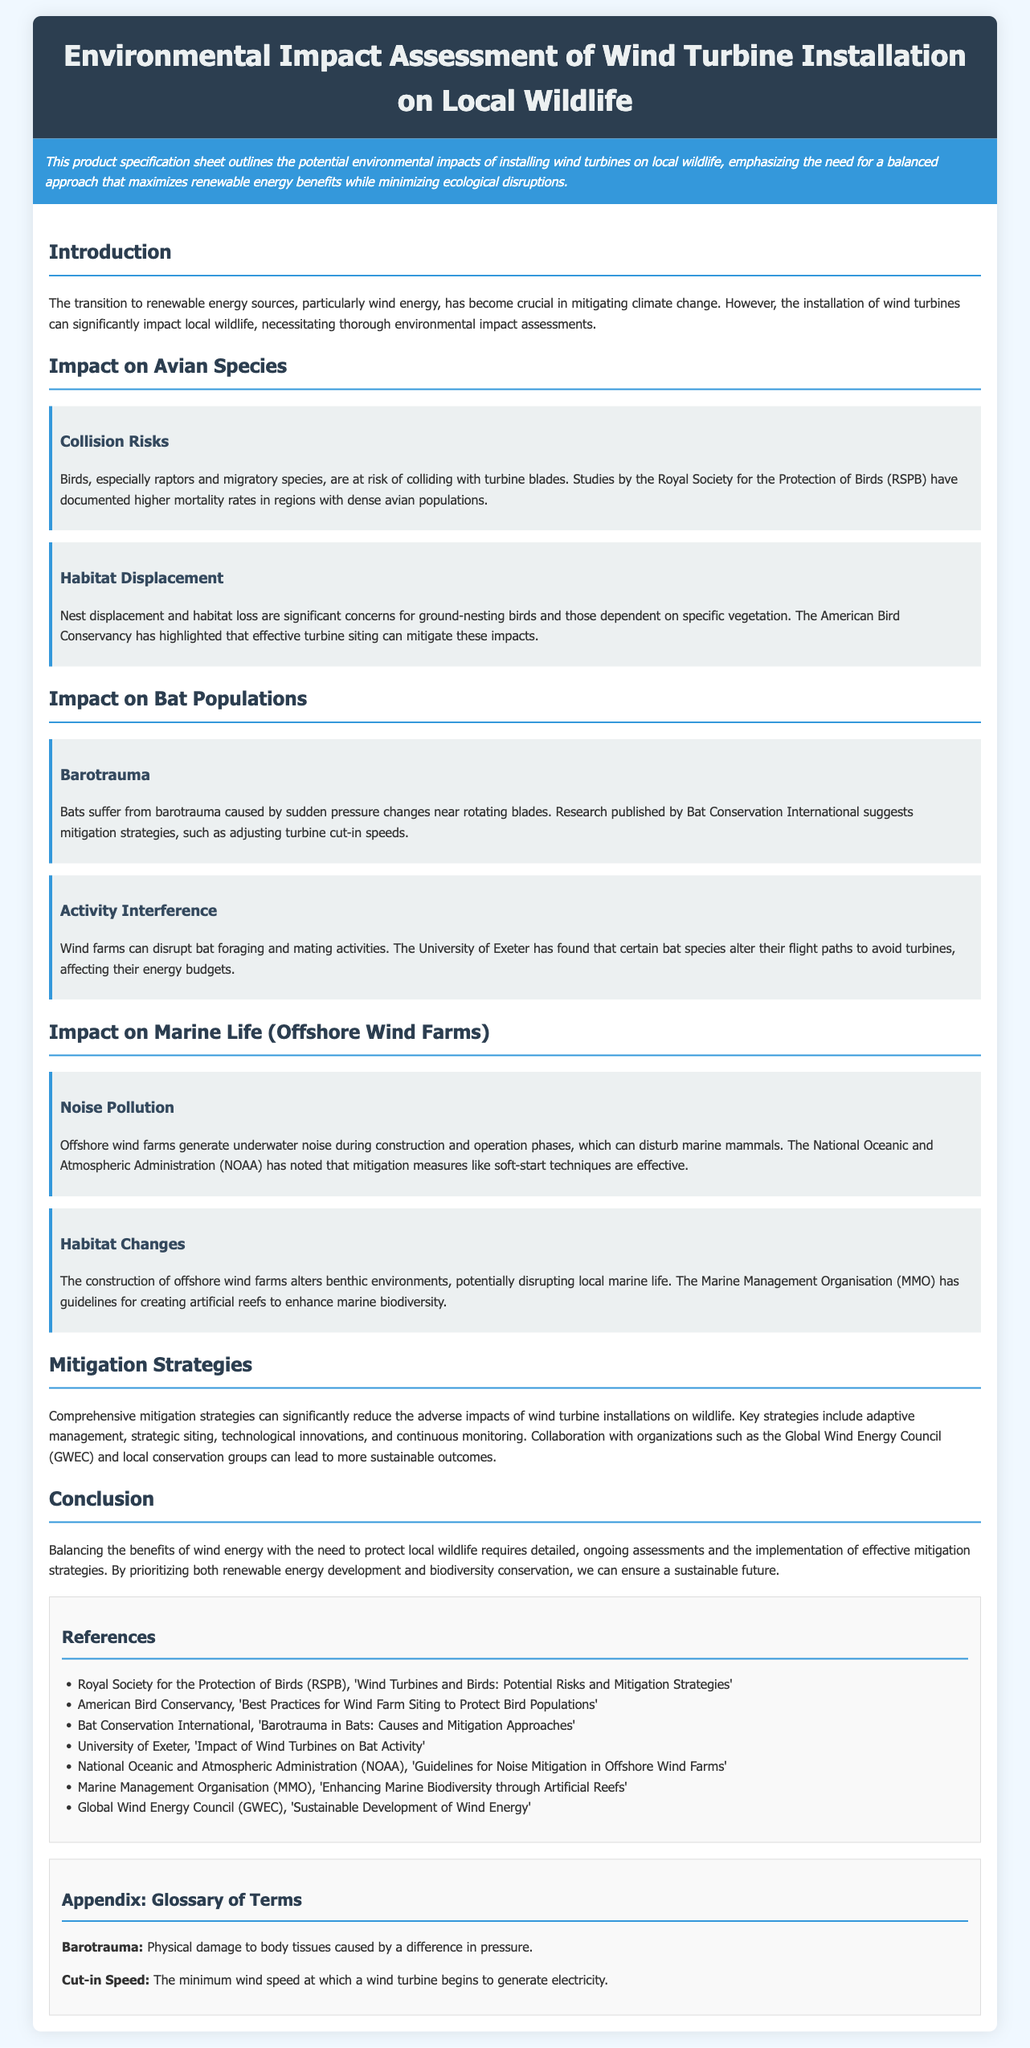What is the title of the document? The title is stated at the top of the document, indicating the focus of the assessment.
Answer: Environmental Impact Assessment of Wind Turbine Installation on Local Wildlife What organization published a study documenting higher mortality rates in birds? The Royal Society for the Protection of Birds (RSPB) is mentioned for its research on avian species.
Answer: Royal Society for the Protection of Birds (RSPB) What term is used to describe physical damage to body tissues caused by pressure differences? The term is defined in the appendix section under Glossary of Terms.
Answer: Barotrauma Which species' population is affected by habitat displacement? The document specifically mentions ground-nesting birds concerning habitat loss.
Answer: Ground-nesting birds What mitigation strategy is mentioned for bats suffering from barotrauma? Adjusting turbine cut-in speeds is highlighted as a mitigation approach for bats.
Answer: Adjusting turbine cut-in speeds What type of wildlife is primarily affected by noise pollution in offshore wind farms? The document refers to marine mammals being disturbed by underwater noise.
Answer: Marine mammals Which organization has guidelines for creating artificial reefs? The Marine Management Organisation (MMO) is mentioned as having guidelines in this area.
Answer: Marine Management Organisation (MMO) What is the primary focus of the executive summary? The executive summary highlights the balance needed in wind turbine installation regarding renewable energy and ecological impacts.
Answer: Balancing renewable energy benefits with ecological disruptions 